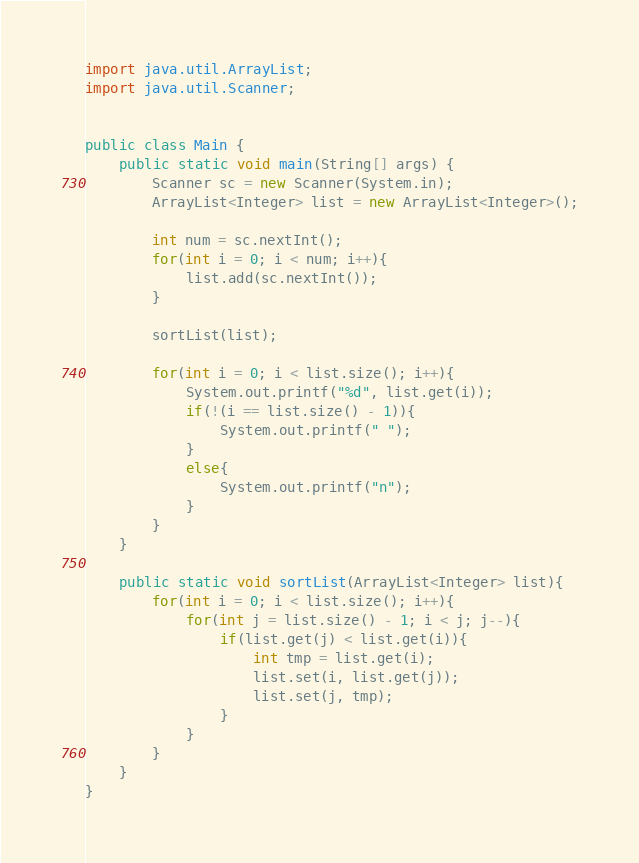<code> <loc_0><loc_0><loc_500><loc_500><_Java_>import java.util.ArrayList;
import java.util.Scanner;
 
 
public class Main {
    public static void main(String[] args) {
        Scanner sc = new Scanner(System.in);
        ArrayList<Integer> list = new ArrayList<Integer>();
         
        int num = sc.nextInt();
        for(int i = 0; i < num; i++){
            list.add(sc.nextInt());
        }
         
        sortList(list);
         
        for(int i = 0; i < list.size(); i++){
            System.out.printf("%d", list.get(i));
            if(!(i == list.size() - 1)){
                System.out.printf(" ");
            }
            else{
                System.out.printf("n");
            }
        }
    }
     
    public static void sortList(ArrayList<Integer> list){
        for(int i = 0; i < list.size(); i++){
            for(int j = list.size() - 1; i < j; j--){
                if(list.get(j) < list.get(i)){
                    int tmp = list.get(i);
                    list.set(i, list.get(j));
                    list.set(j, tmp);
                }
            }
        }
    }
}</code> 